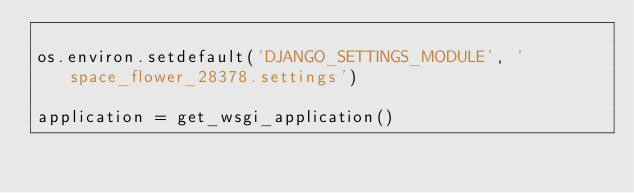Convert code to text. <code><loc_0><loc_0><loc_500><loc_500><_Python_>
os.environ.setdefault('DJANGO_SETTINGS_MODULE', 'space_flower_28378.settings')

application = get_wsgi_application()
</code> 